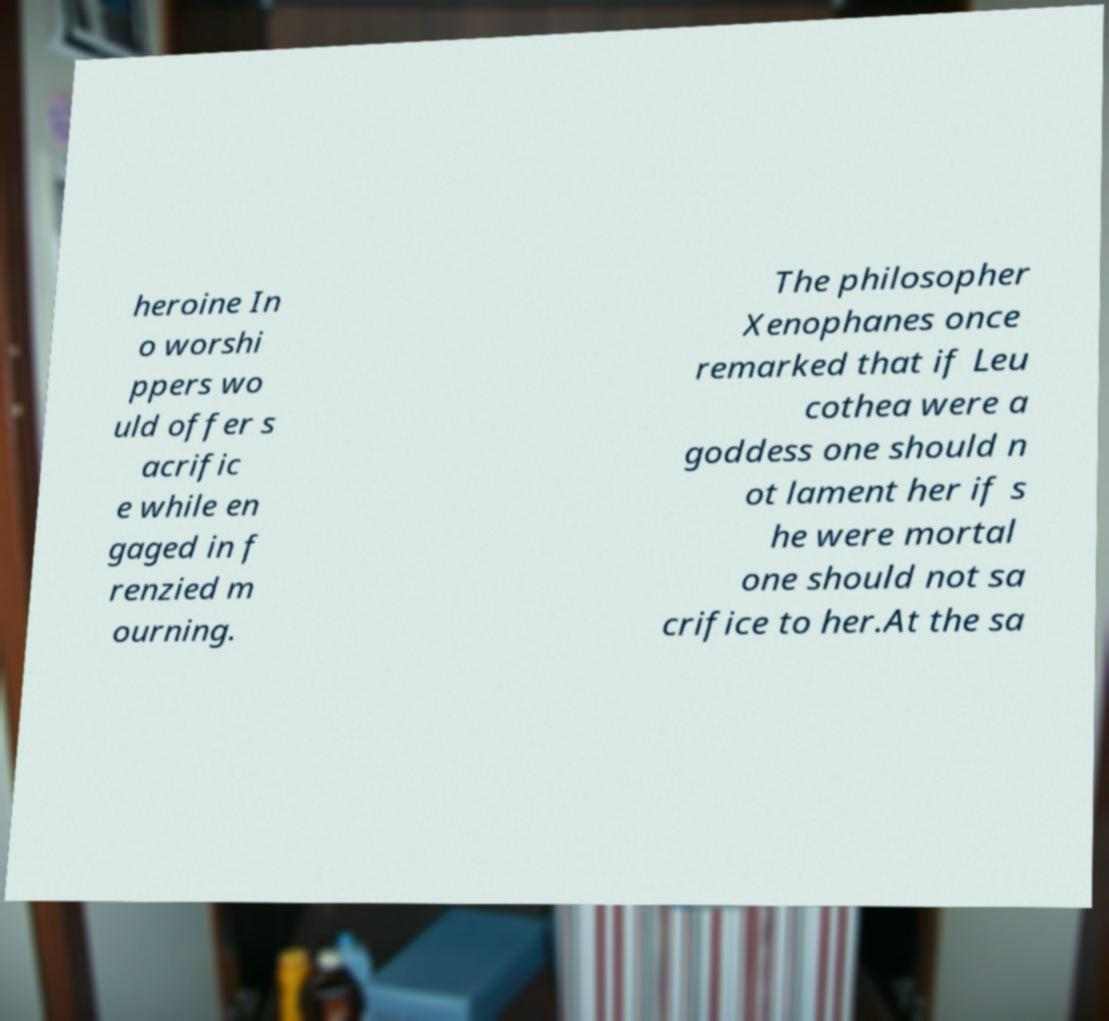There's text embedded in this image that I need extracted. Can you transcribe it verbatim? heroine In o worshi ppers wo uld offer s acrific e while en gaged in f renzied m ourning. The philosopher Xenophanes once remarked that if Leu cothea were a goddess one should n ot lament her if s he were mortal one should not sa crifice to her.At the sa 